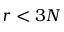Convert formula to latex. <formula><loc_0><loc_0><loc_500><loc_500>r < 3 N</formula> 